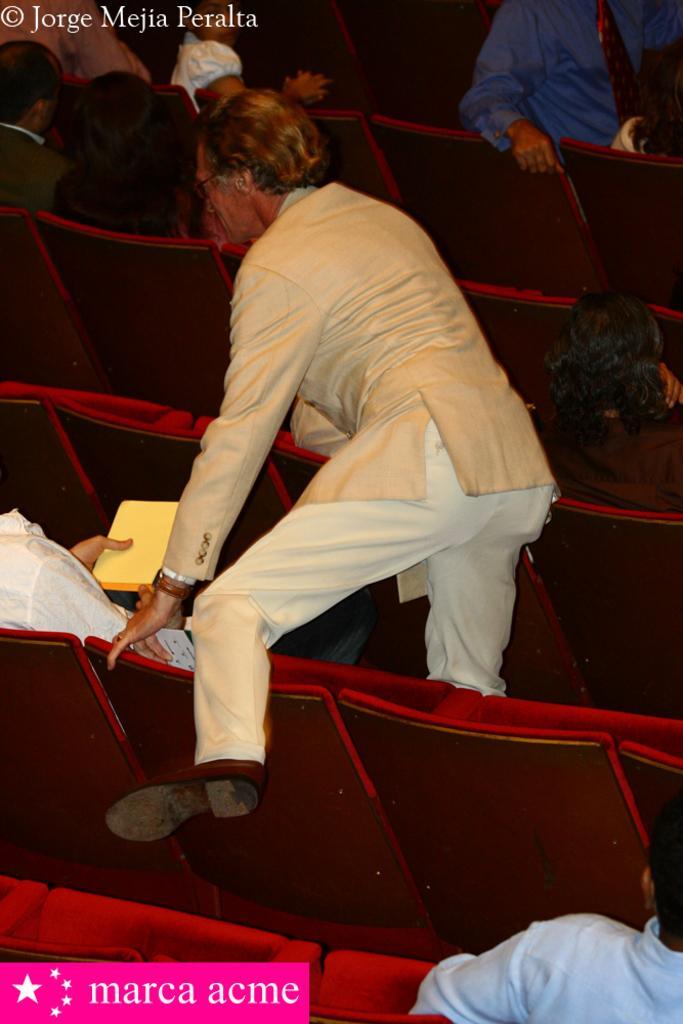Could you give a brief overview of what you see in this image? In the center there is a man standing on the seat and there are people sitting in the seats. 